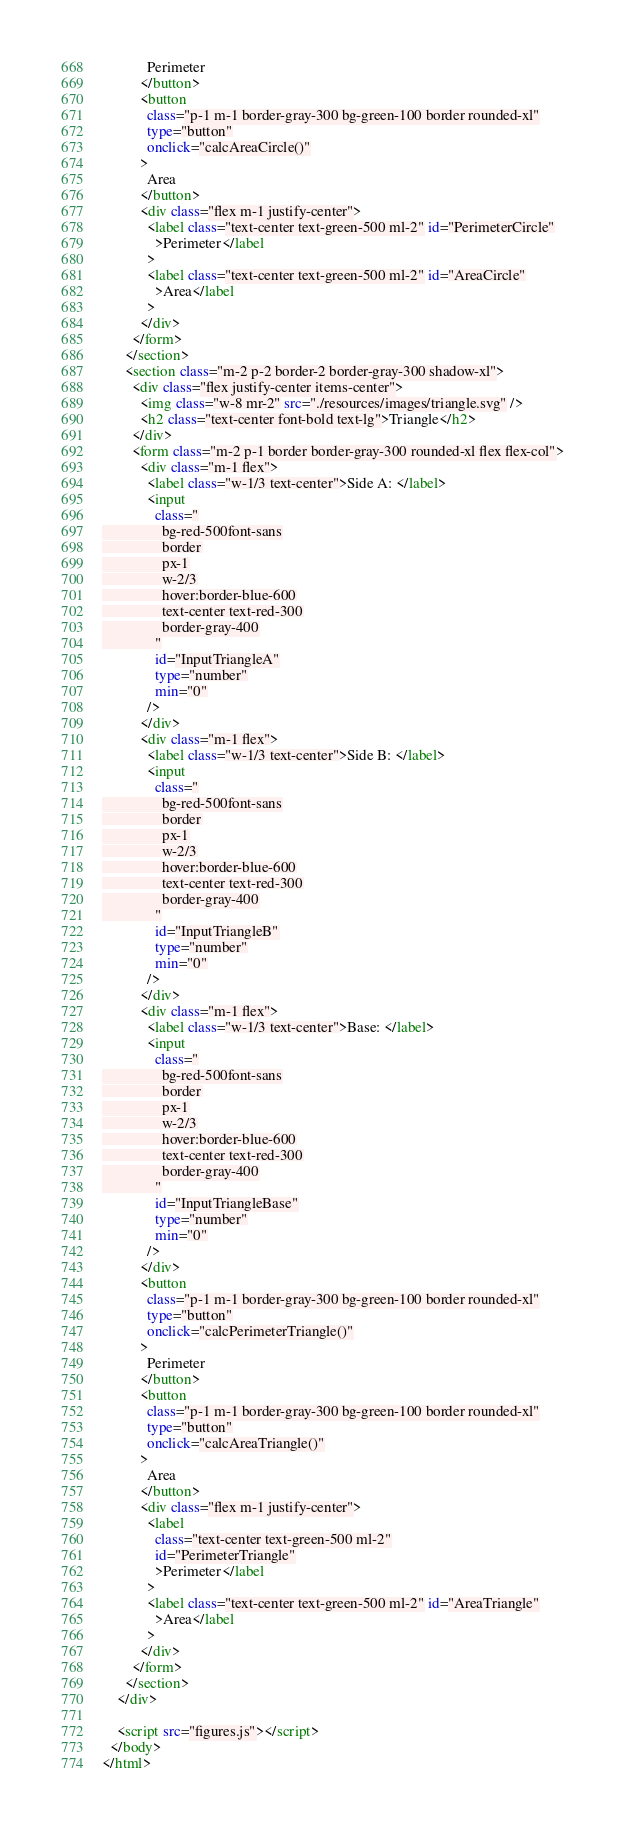<code> <loc_0><loc_0><loc_500><loc_500><_HTML_>            Perimeter
          </button>
          <button
            class="p-1 m-1 border-gray-300 bg-green-100 border rounded-xl"
            type="button"
            onclick="calcAreaCircle()"
          >
            Area
          </button>
          <div class="flex m-1 justify-center">
            <label class="text-center text-green-500 ml-2" id="PerimeterCircle"
              >Perimeter</label
            >
            <label class="text-center text-green-500 ml-2" id="AreaCircle"
              >Area</label
            >
          </div>
        </form>
      </section>
      <section class="m-2 p-2 border-2 border-gray-300 shadow-xl">
        <div class="flex justify-center items-center">
          <img class="w-8 mr-2" src="./resources/images/triangle.svg" />
          <h2 class="text-center font-bold text-lg">Triangle</h2>
        </div>
        <form class="m-2 p-1 border border-gray-300 rounded-xl flex flex-col">
          <div class="m-1 flex">
            <label class="w-1/3 text-center">Side A: </label>
            <input
              class="
                bg-red-500font-sans
                border
                px-1
                w-2/3
                hover:border-blue-600
                text-center text-red-300
                border-gray-400
              "
              id="InputTriangleA"
              type="number"
              min="0"
            />
          </div>
          <div class="m-1 flex">
            <label class="w-1/3 text-center">Side B: </label>
            <input
              class="
                bg-red-500font-sans
                border
                px-1
                w-2/3
                hover:border-blue-600
                text-center text-red-300
                border-gray-400
              "
              id="InputTriangleB"
              type="number"
              min="0"
            />
          </div>
          <div class="m-1 flex">
            <label class="w-1/3 text-center">Base: </label>
            <input
              class="
                bg-red-500font-sans
                border
                px-1
                w-2/3
                hover:border-blue-600
                text-center text-red-300
                border-gray-400
              "
              id="InputTriangleBase"
              type="number"
              min="0"
            />
          </div>
          <button
            class="p-1 m-1 border-gray-300 bg-green-100 border rounded-xl"
            type="button"
            onclick="calcPerimeterTriangle()"
          >
            Perimeter
          </button>
          <button
            class="p-1 m-1 border-gray-300 bg-green-100 border rounded-xl"
            type="button"
            onclick="calcAreaTriangle()"
          >
            Area
          </button>
          <div class="flex m-1 justify-center">
            <label
              class="text-center text-green-500 ml-2"
              id="PerimeterTriangle"
              >Perimeter</label
            >
            <label class="text-center text-green-500 ml-2" id="AreaTriangle"
              >Area</label
            >
          </div>
        </form>
      </section>
    </div>

    <script src="figures.js"></script>
  </body>
</html>
</code> 